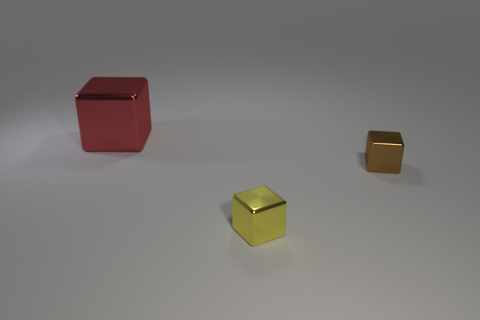Is the object that is in front of the brown shiny object made of the same material as the small block that is on the right side of the yellow cube?
Ensure brevity in your answer.  Yes. Is there any other thing that has the same shape as the big metallic object?
Ensure brevity in your answer.  Yes. Is the material of the big red thing the same as the tiny thing that is right of the small yellow thing?
Provide a short and direct response. Yes. There is a small shiny cube behind the thing in front of the tiny thing behind the small yellow cube; what color is it?
Offer a very short reply. Brown. There is another metal object that is the same size as the brown metal object; what shape is it?
Make the answer very short. Cube. Are there any other things that have the same size as the yellow cube?
Offer a terse response. Yes. Is the size of the metallic block that is on the left side of the small yellow block the same as the cube right of the yellow metal thing?
Make the answer very short. No. There is a cube that is to the right of the tiny yellow metallic object; what size is it?
Offer a terse response. Small. What is the color of the cube that is the same size as the yellow thing?
Provide a short and direct response. Brown. Do the red thing and the brown cube have the same size?
Offer a very short reply. No. 